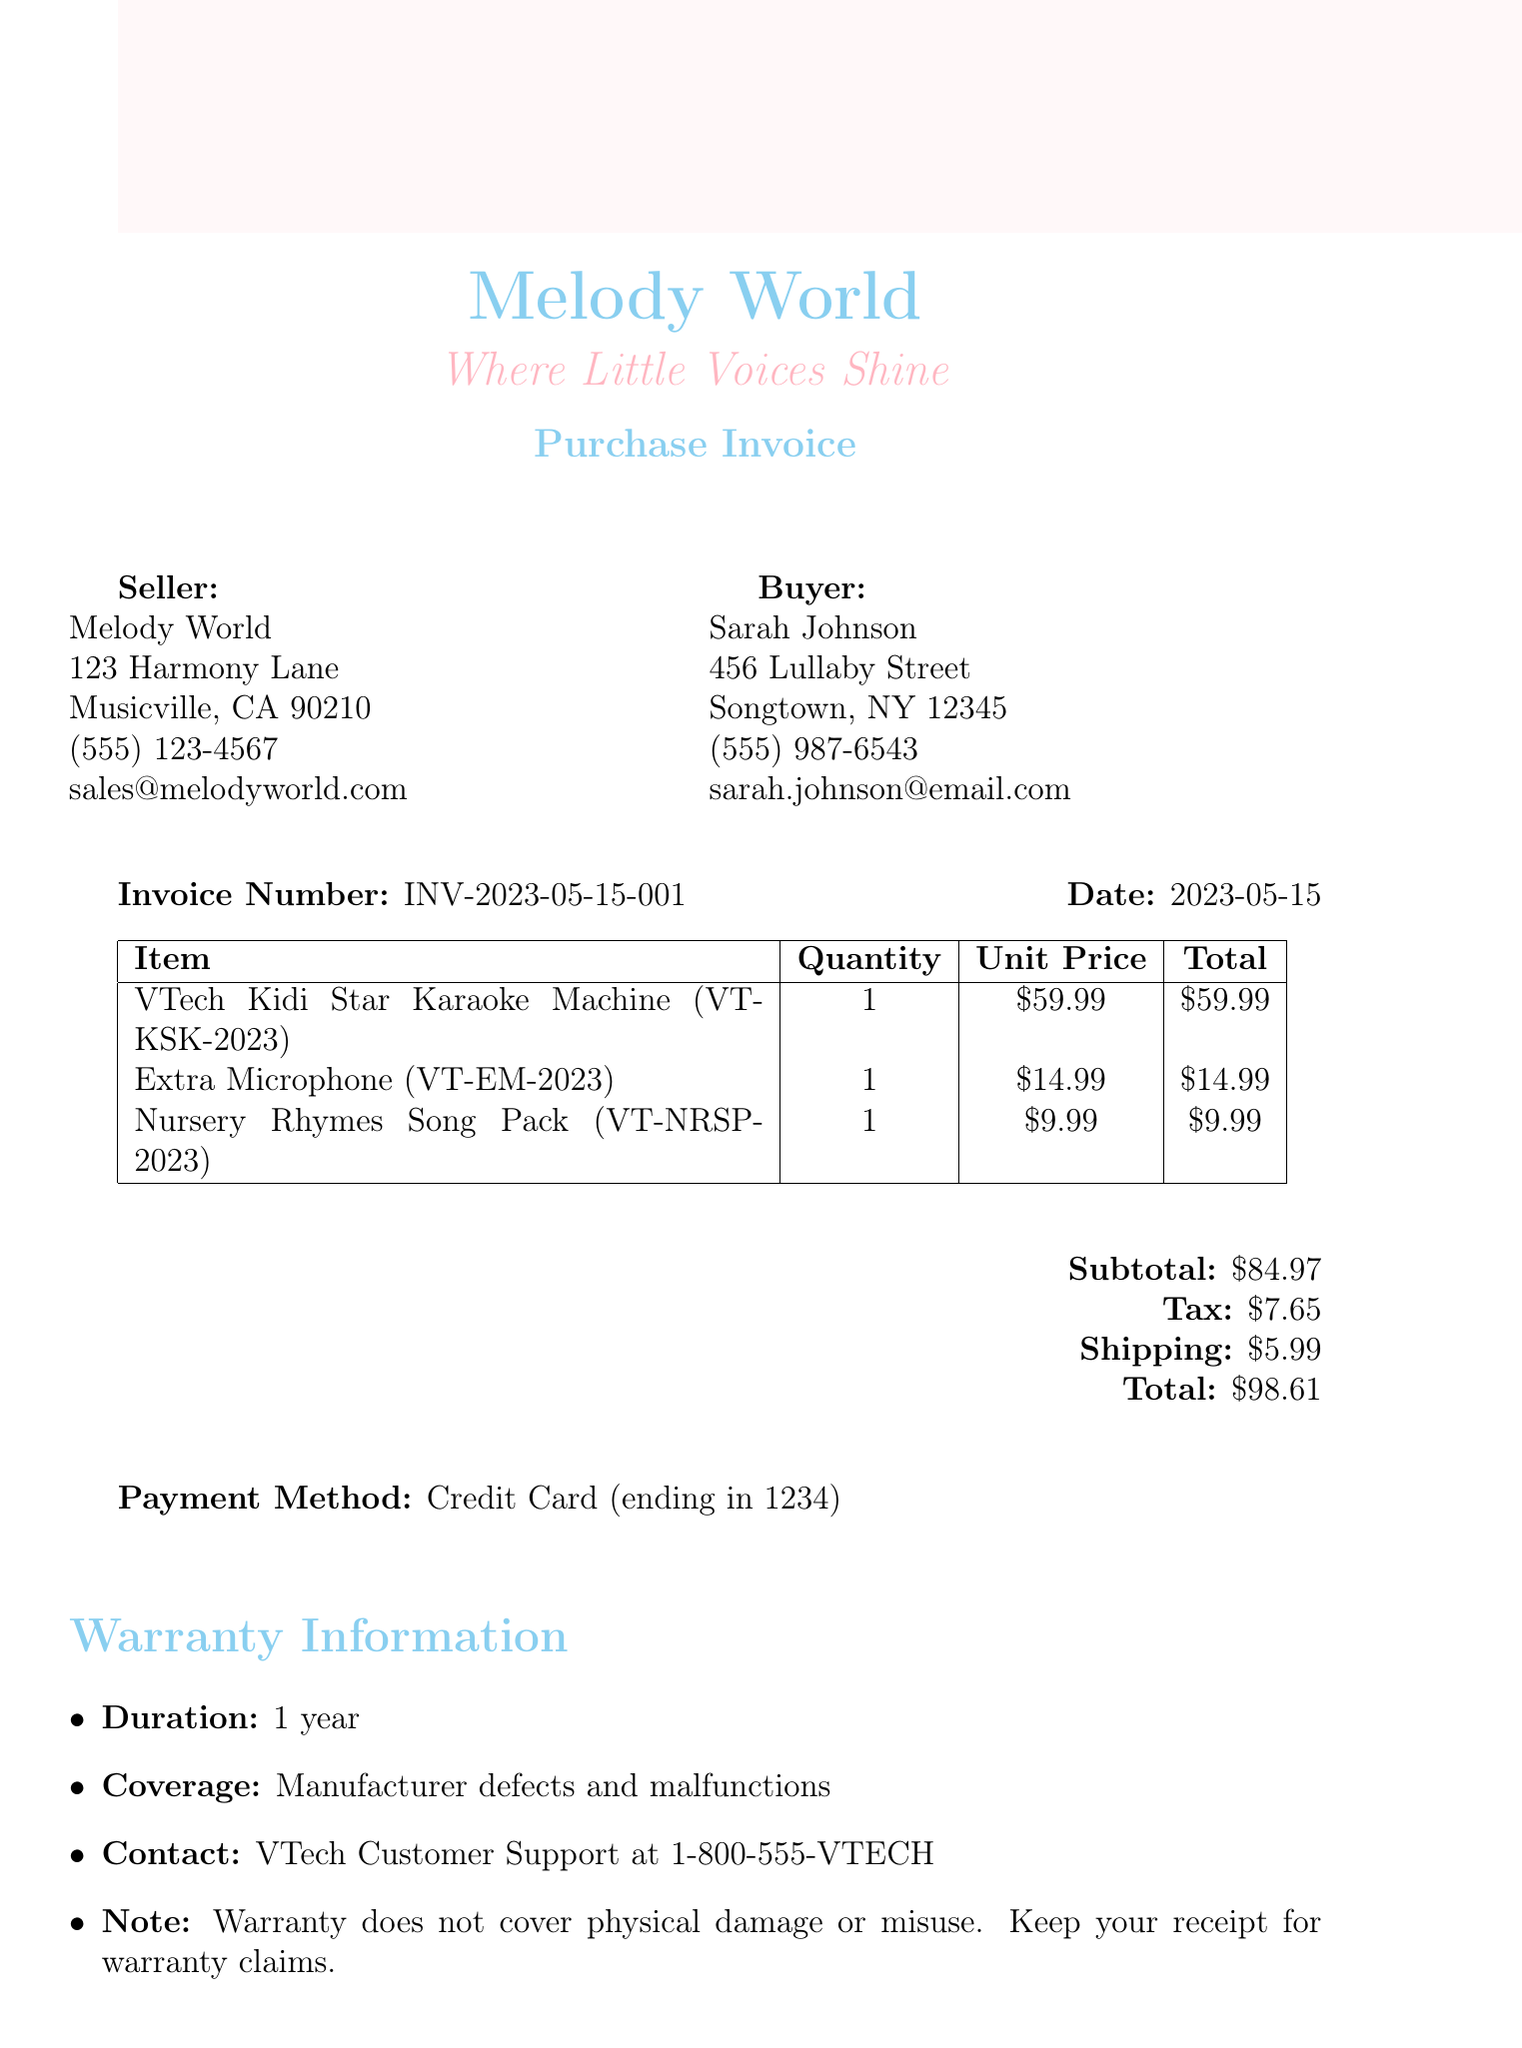What is the invoice number? The invoice number is specified in the document header section as part of the invoice details.
Answer: INV-2023-05-15-001 Who is the seller? The seller's name is indicated at the top of the document under the seller section.
Answer: Melody World What is the total price? The total price is calculated and presented at the end of the invoice summary.
Answer: 98.61 What is the warranty duration? The warranty information section states the length of coverage for the product.
Answer: 1 year What items are included in the purchase? The document provides a detailed table listing the purchased items, their quantities, and prices.
Answer: VTech Kidi Star Karaoke Machine, Extra Microphone, Nursery Rhymes Song Pack What is the return policy condition? The return policy outlines the condition under which returns are accepted, which can be found in the policy details.
Answer: Unused and in original packaging What is the restocking fee for opened items? The return policy includes specific fees for different scenarios related to returned items.
Answer: 10% for opened items How can I contact customer support for warranty claims? The warranty section specifies the customer support contact information for warranty inquiries.
Answer: VTech Customer Support at 1-800-555-VTECH What is the educational note's purpose? The educational note describes the benefits of the karaoke machine in relation to child development.
Answer: Enhancing your child's language skills through singing 